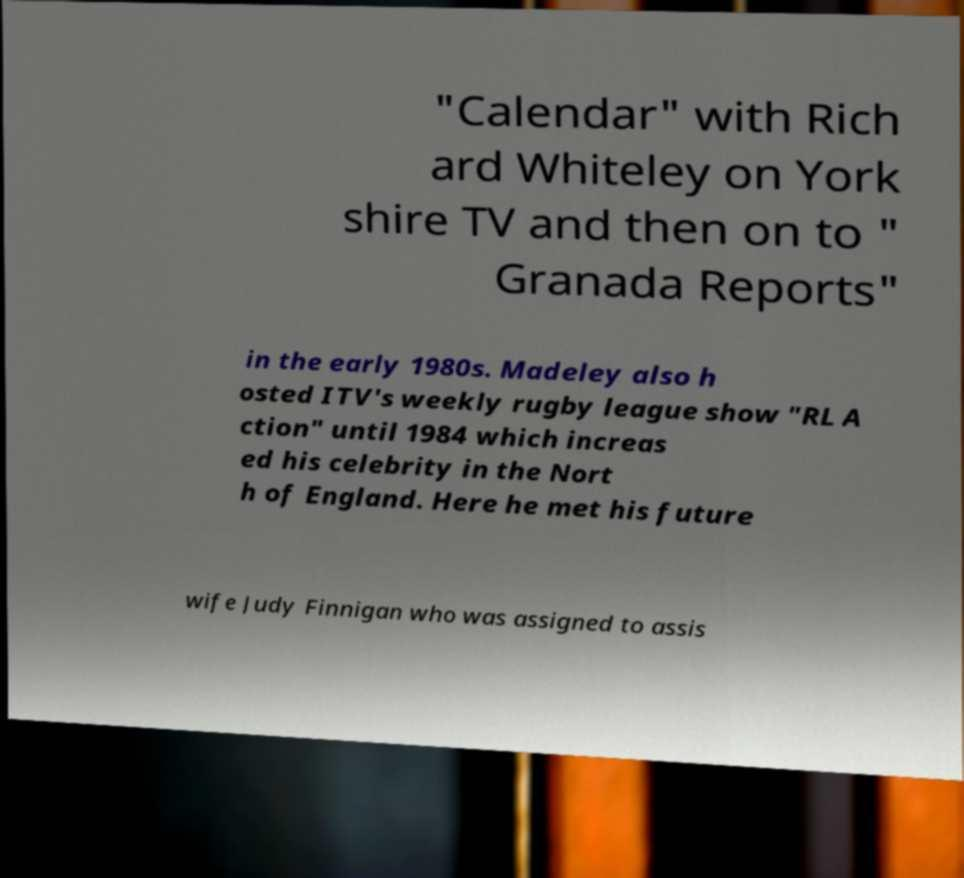Can you accurately transcribe the text from the provided image for me? "Calendar" with Rich ard Whiteley on York shire TV and then on to " Granada Reports" in the early 1980s. Madeley also h osted ITV's weekly rugby league show "RL A ction" until 1984 which increas ed his celebrity in the Nort h of England. Here he met his future wife Judy Finnigan who was assigned to assis 